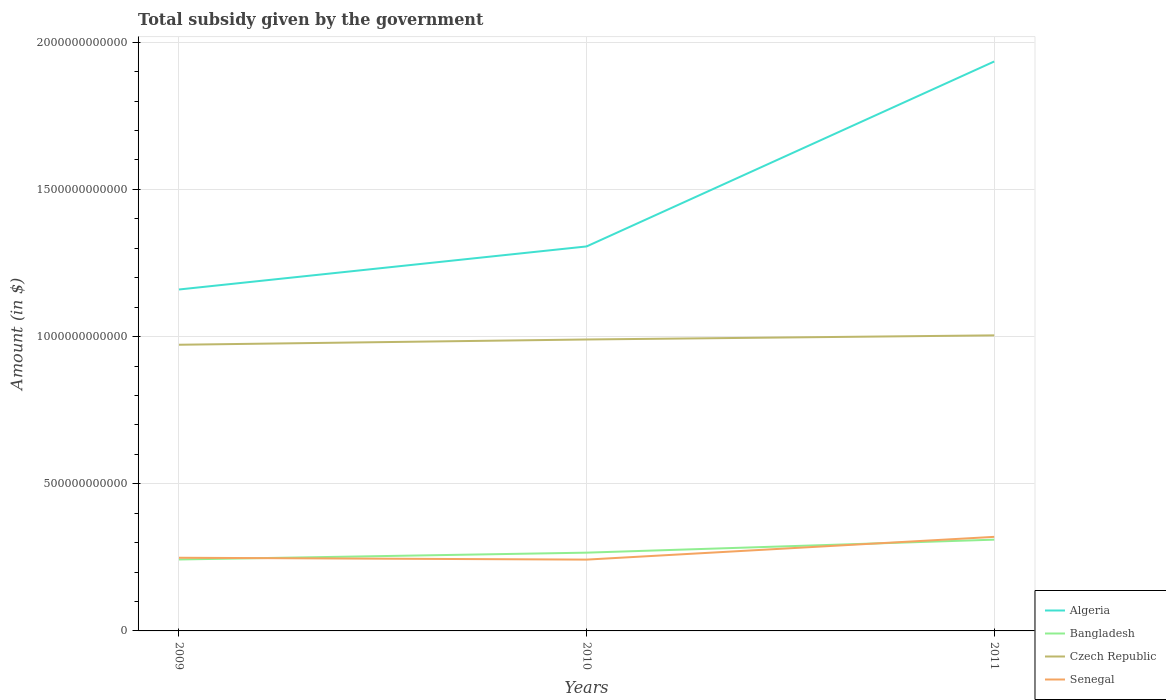Across all years, what is the maximum total revenue collected by the government in Senegal?
Ensure brevity in your answer.  2.42e+11. What is the total total revenue collected by the government in Senegal in the graph?
Your answer should be very brief. -7.73e+1. What is the difference between the highest and the second highest total revenue collected by the government in Czech Republic?
Offer a very short reply. 3.19e+1. What is the difference between two consecutive major ticks on the Y-axis?
Offer a very short reply. 5.00e+11. Does the graph contain any zero values?
Provide a short and direct response. No. How many legend labels are there?
Your answer should be very brief. 4. What is the title of the graph?
Make the answer very short. Total subsidy given by the government. Does "Swaziland" appear as one of the legend labels in the graph?
Make the answer very short. No. What is the label or title of the Y-axis?
Give a very brief answer. Amount (in $). What is the Amount (in $) in Algeria in 2009?
Your answer should be compact. 1.16e+12. What is the Amount (in $) in Bangladesh in 2009?
Provide a short and direct response. 2.43e+11. What is the Amount (in $) in Czech Republic in 2009?
Offer a terse response. 9.72e+11. What is the Amount (in $) of Senegal in 2009?
Offer a very short reply. 2.49e+11. What is the Amount (in $) of Algeria in 2010?
Keep it short and to the point. 1.31e+12. What is the Amount (in $) of Bangladesh in 2010?
Ensure brevity in your answer.  2.66e+11. What is the Amount (in $) in Czech Republic in 2010?
Provide a succinct answer. 9.90e+11. What is the Amount (in $) in Senegal in 2010?
Your answer should be very brief. 2.42e+11. What is the Amount (in $) of Algeria in 2011?
Your answer should be very brief. 1.93e+12. What is the Amount (in $) in Bangladesh in 2011?
Your answer should be compact. 3.10e+11. What is the Amount (in $) in Czech Republic in 2011?
Your answer should be very brief. 1.00e+12. What is the Amount (in $) of Senegal in 2011?
Your answer should be very brief. 3.20e+11. Across all years, what is the maximum Amount (in $) of Algeria?
Give a very brief answer. 1.93e+12. Across all years, what is the maximum Amount (in $) of Bangladesh?
Your response must be concise. 3.10e+11. Across all years, what is the maximum Amount (in $) of Czech Republic?
Give a very brief answer. 1.00e+12. Across all years, what is the maximum Amount (in $) in Senegal?
Ensure brevity in your answer.  3.20e+11. Across all years, what is the minimum Amount (in $) in Algeria?
Keep it short and to the point. 1.16e+12. Across all years, what is the minimum Amount (in $) of Bangladesh?
Provide a short and direct response. 2.43e+11. Across all years, what is the minimum Amount (in $) of Czech Republic?
Provide a short and direct response. 9.72e+11. Across all years, what is the minimum Amount (in $) of Senegal?
Keep it short and to the point. 2.42e+11. What is the total Amount (in $) in Algeria in the graph?
Your answer should be very brief. 4.40e+12. What is the total Amount (in $) in Bangladesh in the graph?
Offer a very short reply. 8.19e+11. What is the total Amount (in $) of Czech Republic in the graph?
Provide a short and direct response. 2.97e+12. What is the total Amount (in $) in Senegal in the graph?
Your response must be concise. 8.10e+11. What is the difference between the Amount (in $) in Algeria in 2009 and that in 2010?
Offer a terse response. -1.46e+11. What is the difference between the Amount (in $) in Bangladesh in 2009 and that in 2010?
Keep it short and to the point. -2.32e+1. What is the difference between the Amount (in $) of Czech Republic in 2009 and that in 2010?
Provide a succinct answer. -1.79e+1. What is the difference between the Amount (in $) in Senegal in 2009 and that in 2010?
Offer a terse response. 6.30e+09. What is the difference between the Amount (in $) in Algeria in 2009 and that in 2011?
Offer a terse response. -7.75e+11. What is the difference between the Amount (in $) of Bangladesh in 2009 and that in 2011?
Provide a succinct answer. -6.74e+1. What is the difference between the Amount (in $) of Czech Republic in 2009 and that in 2011?
Make the answer very short. -3.19e+1. What is the difference between the Amount (in $) in Senegal in 2009 and that in 2011?
Ensure brevity in your answer.  -7.10e+1. What is the difference between the Amount (in $) in Algeria in 2010 and that in 2011?
Provide a short and direct response. -6.28e+11. What is the difference between the Amount (in $) of Bangladesh in 2010 and that in 2011?
Keep it short and to the point. -4.42e+1. What is the difference between the Amount (in $) in Czech Republic in 2010 and that in 2011?
Ensure brevity in your answer.  -1.40e+1. What is the difference between the Amount (in $) of Senegal in 2010 and that in 2011?
Ensure brevity in your answer.  -7.73e+1. What is the difference between the Amount (in $) in Algeria in 2009 and the Amount (in $) in Bangladesh in 2010?
Ensure brevity in your answer.  8.94e+11. What is the difference between the Amount (in $) in Algeria in 2009 and the Amount (in $) in Czech Republic in 2010?
Keep it short and to the point. 1.70e+11. What is the difference between the Amount (in $) in Algeria in 2009 and the Amount (in $) in Senegal in 2010?
Keep it short and to the point. 9.18e+11. What is the difference between the Amount (in $) of Bangladesh in 2009 and the Amount (in $) of Czech Republic in 2010?
Give a very brief answer. -7.47e+11. What is the difference between the Amount (in $) in Bangladesh in 2009 and the Amount (in $) in Senegal in 2010?
Your response must be concise. 4.14e+08. What is the difference between the Amount (in $) in Czech Republic in 2009 and the Amount (in $) in Senegal in 2010?
Offer a very short reply. 7.30e+11. What is the difference between the Amount (in $) of Algeria in 2009 and the Amount (in $) of Bangladesh in 2011?
Provide a succinct answer. 8.50e+11. What is the difference between the Amount (in $) in Algeria in 2009 and the Amount (in $) in Czech Republic in 2011?
Make the answer very short. 1.56e+11. What is the difference between the Amount (in $) of Algeria in 2009 and the Amount (in $) of Senegal in 2011?
Give a very brief answer. 8.40e+11. What is the difference between the Amount (in $) in Bangladesh in 2009 and the Amount (in $) in Czech Republic in 2011?
Make the answer very short. -7.61e+11. What is the difference between the Amount (in $) in Bangladesh in 2009 and the Amount (in $) in Senegal in 2011?
Your response must be concise. -7.69e+1. What is the difference between the Amount (in $) in Czech Republic in 2009 and the Amount (in $) in Senegal in 2011?
Your answer should be very brief. 6.53e+11. What is the difference between the Amount (in $) of Algeria in 2010 and the Amount (in $) of Bangladesh in 2011?
Your response must be concise. 9.96e+11. What is the difference between the Amount (in $) of Algeria in 2010 and the Amount (in $) of Czech Republic in 2011?
Your answer should be compact. 3.02e+11. What is the difference between the Amount (in $) in Algeria in 2010 and the Amount (in $) in Senegal in 2011?
Make the answer very short. 9.87e+11. What is the difference between the Amount (in $) in Bangladesh in 2010 and the Amount (in $) in Czech Republic in 2011?
Give a very brief answer. -7.38e+11. What is the difference between the Amount (in $) in Bangladesh in 2010 and the Amount (in $) in Senegal in 2011?
Your response must be concise. -5.37e+1. What is the difference between the Amount (in $) in Czech Republic in 2010 and the Amount (in $) in Senegal in 2011?
Keep it short and to the point. 6.71e+11. What is the average Amount (in $) of Algeria per year?
Ensure brevity in your answer.  1.47e+12. What is the average Amount (in $) of Bangladesh per year?
Your answer should be compact. 2.73e+11. What is the average Amount (in $) in Czech Republic per year?
Offer a very short reply. 9.89e+11. What is the average Amount (in $) of Senegal per year?
Provide a succinct answer. 2.70e+11. In the year 2009, what is the difference between the Amount (in $) in Algeria and Amount (in $) in Bangladesh?
Your answer should be very brief. 9.17e+11. In the year 2009, what is the difference between the Amount (in $) of Algeria and Amount (in $) of Czech Republic?
Offer a very short reply. 1.88e+11. In the year 2009, what is the difference between the Amount (in $) in Algeria and Amount (in $) in Senegal?
Give a very brief answer. 9.11e+11. In the year 2009, what is the difference between the Amount (in $) of Bangladesh and Amount (in $) of Czech Republic?
Offer a terse response. -7.30e+11. In the year 2009, what is the difference between the Amount (in $) in Bangladesh and Amount (in $) in Senegal?
Ensure brevity in your answer.  -5.89e+09. In the year 2009, what is the difference between the Amount (in $) in Czech Republic and Amount (in $) in Senegal?
Ensure brevity in your answer.  7.24e+11. In the year 2010, what is the difference between the Amount (in $) in Algeria and Amount (in $) in Bangladesh?
Provide a succinct answer. 1.04e+12. In the year 2010, what is the difference between the Amount (in $) in Algeria and Amount (in $) in Czech Republic?
Your answer should be very brief. 3.16e+11. In the year 2010, what is the difference between the Amount (in $) in Algeria and Amount (in $) in Senegal?
Provide a short and direct response. 1.06e+12. In the year 2010, what is the difference between the Amount (in $) in Bangladesh and Amount (in $) in Czech Republic?
Make the answer very short. -7.24e+11. In the year 2010, what is the difference between the Amount (in $) in Bangladesh and Amount (in $) in Senegal?
Your answer should be compact. 2.36e+1. In the year 2010, what is the difference between the Amount (in $) of Czech Republic and Amount (in $) of Senegal?
Your response must be concise. 7.48e+11. In the year 2011, what is the difference between the Amount (in $) in Algeria and Amount (in $) in Bangladesh?
Make the answer very short. 1.62e+12. In the year 2011, what is the difference between the Amount (in $) in Algeria and Amount (in $) in Czech Republic?
Provide a short and direct response. 9.31e+11. In the year 2011, what is the difference between the Amount (in $) in Algeria and Amount (in $) in Senegal?
Your answer should be very brief. 1.62e+12. In the year 2011, what is the difference between the Amount (in $) in Bangladesh and Amount (in $) in Czech Republic?
Provide a succinct answer. -6.94e+11. In the year 2011, what is the difference between the Amount (in $) in Bangladesh and Amount (in $) in Senegal?
Provide a short and direct response. -9.52e+09. In the year 2011, what is the difference between the Amount (in $) of Czech Republic and Amount (in $) of Senegal?
Keep it short and to the point. 6.85e+11. What is the ratio of the Amount (in $) in Algeria in 2009 to that in 2010?
Your answer should be compact. 0.89. What is the ratio of the Amount (in $) of Bangladesh in 2009 to that in 2010?
Your answer should be very brief. 0.91. What is the ratio of the Amount (in $) in Czech Republic in 2009 to that in 2010?
Your response must be concise. 0.98. What is the ratio of the Amount (in $) of Senegal in 2009 to that in 2010?
Give a very brief answer. 1.03. What is the ratio of the Amount (in $) of Algeria in 2009 to that in 2011?
Provide a short and direct response. 0.6. What is the ratio of the Amount (in $) in Bangladesh in 2009 to that in 2011?
Your answer should be compact. 0.78. What is the ratio of the Amount (in $) in Czech Republic in 2009 to that in 2011?
Make the answer very short. 0.97. What is the ratio of the Amount (in $) in Senegal in 2009 to that in 2011?
Give a very brief answer. 0.78. What is the ratio of the Amount (in $) in Algeria in 2010 to that in 2011?
Provide a succinct answer. 0.68. What is the ratio of the Amount (in $) of Bangladesh in 2010 to that in 2011?
Make the answer very short. 0.86. What is the ratio of the Amount (in $) in Czech Republic in 2010 to that in 2011?
Offer a very short reply. 0.99. What is the ratio of the Amount (in $) of Senegal in 2010 to that in 2011?
Offer a terse response. 0.76. What is the difference between the highest and the second highest Amount (in $) of Algeria?
Offer a very short reply. 6.28e+11. What is the difference between the highest and the second highest Amount (in $) in Bangladesh?
Provide a short and direct response. 4.42e+1. What is the difference between the highest and the second highest Amount (in $) of Czech Republic?
Keep it short and to the point. 1.40e+1. What is the difference between the highest and the second highest Amount (in $) in Senegal?
Your answer should be very brief. 7.10e+1. What is the difference between the highest and the lowest Amount (in $) in Algeria?
Provide a succinct answer. 7.75e+11. What is the difference between the highest and the lowest Amount (in $) of Bangladesh?
Provide a short and direct response. 6.74e+1. What is the difference between the highest and the lowest Amount (in $) of Czech Republic?
Provide a succinct answer. 3.19e+1. What is the difference between the highest and the lowest Amount (in $) of Senegal?
Your response must be concise. 7.73e+1. 